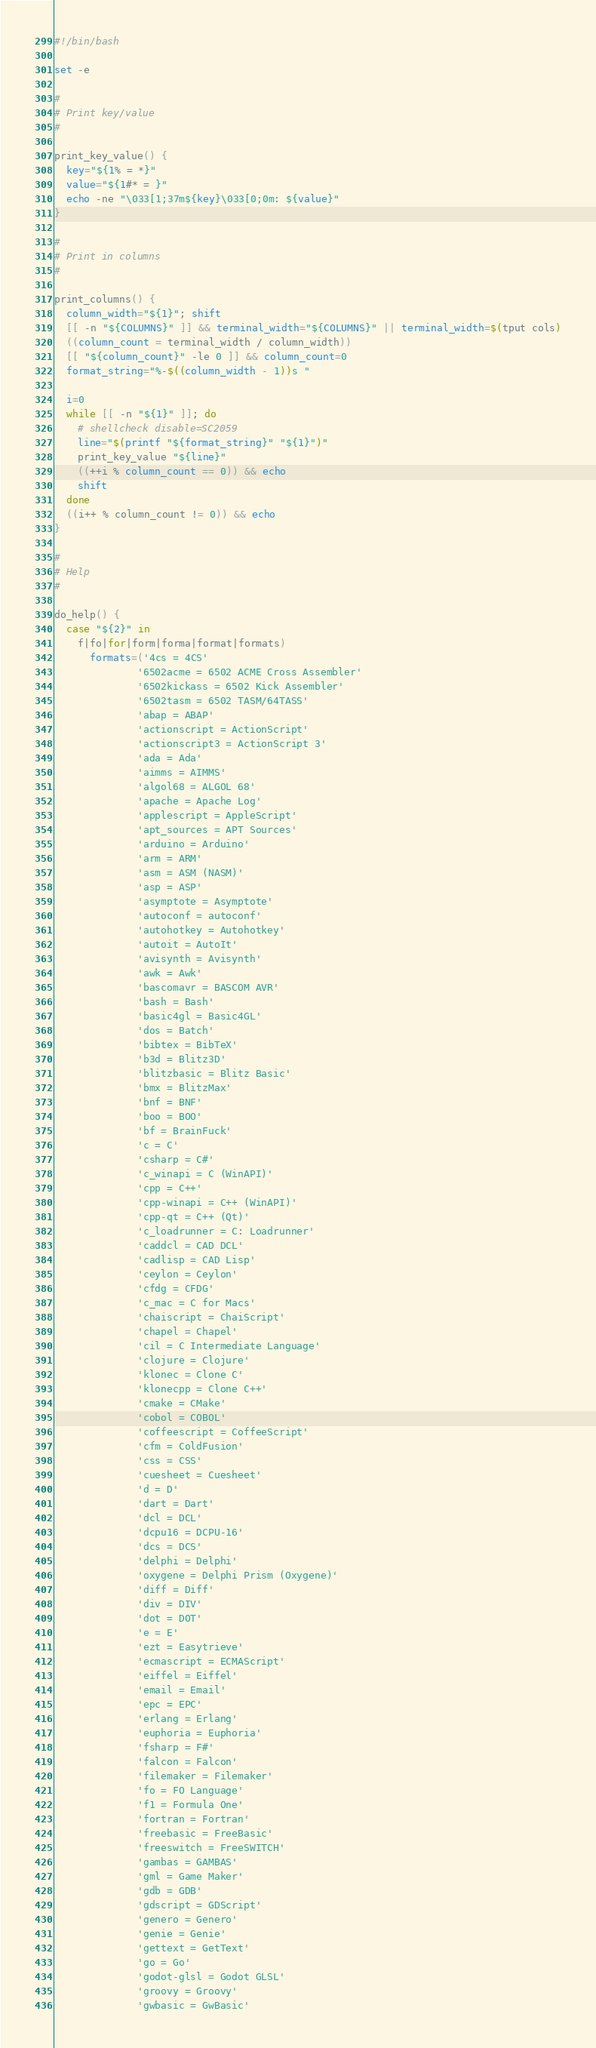<code> <loc_0><loc_0><loc_500><loc_500><_Bash_>#!/bin/bash

set -e

#
# Print key/value
#

print_key_value() {
  key="${1% = *}"
  value="${1#* = }"
  echo -ne "\033[1;37m${key}\033[0;0m: ${value}"
}

#
# Print in columns
#

print_columns() {
  column_width="${1}"; shift
  [[ -n "${COLUMNS}" ]] && terminal_width="${COLUMNS}" || terminal_width=$(tput cols)
  ((column_count = terminal_width / column_width))
  [[ "${column_count}" -le 0 ]] && column_count=0
  format_string="%-$((column_width - 1))s "

  i=0
  while [[ -n "${1}" ]]; do
    # shellcheck disable=SC2059
    line="$(printf "${format_string}" "${1}")"
    print_key_value "${line}"
    ((++i % column_count == 0)) && echo
    shift
  done
  ((i++ % column_count != 0)) && echo
}

#
# Help
#

do_help() {
  case "${2}" in
    f|fo|for|form|forma|format|formats)
      formats=('4cs = 4CS'
              '6502acme = 6502 ACME Cross Assembler'
              '6502kickass = 6502 Kick Assembler'
              '6502tasm = 6502 TASM/64TASS'
              'abap = ABAP'
              'actionscript = ActionScript'
              'actionscript3 = ActionScript 3'
              'ada = Ada'
              'aimms = AIMMS'
              'algol68 = ALGOL 68'
              'apache = Apache Log'
              'applescript = AppleScript'
              'apt_sources = APT Sources'
              'arduino = Arduino'
              'arm = ARM'
              'asm = ASM (NASM)'
              'asp = ASP'
              'asymptote = Asymptote'
              'autoconf = autoconf'
              'autohotkey = Autohotkey'
              'autoit = AutoIt'
              'avisynth = Avisynth'
              'awk = Awk'
              'bascomavr = BASCOM AVR'
              'bash = Bash'
              'basic4gl = Basic4GL'
              'dos = Batch'
              'bibtex = BibTeX'
              'b3d = Blitz3D'
              'blitzbasic = Blitz Basic'
              'bmx = BlitzMax'
              'bnf = BNF'
              'boo = BOO'
              'bf = BrainFuck'
              'c = C'
              'csharp = C#'
              'c_winapi = C (WinAPI)'
              'cpp = C++'
              'cpp-winapi = C++ (WinAPI)'
              'cpp-qt = C++ (Qt)'
              'c_loadrunner = C: Loadrunner'
              'caddcl = CAD DCL'
              'cadlisp = CAD Lisp'
              'ceylon = Ceylon'
              'cfdg = CFDG'
              'c_mac = C for Macs'
              'chaiscript = ChaiScript'
              'chapel = Chapel'
              'cil = C Intermediate Language'
              'clojure = Clojure'
              'klonec = Clone C'
              'klonecpp = Clone C++'
              'cmake = CMake'
              'cobol = COBOL'
              'coffeescript = CoffeeScript'
              'cfm = ColdFusion'
              'css = CSS'
              'cuesheet = Cuesheet'
              'd = D'
              'dart = Dart'
              'dcl = DCL'
              'dcpu16 = DCPU-16'
              'dcs = DCS'
              'delphi = Delphi'
              'oxygene = Delphi Prism (Oxygene)'
              'diff = Diff'
              'div = DIV'
              'dot = DOT'
              'e = E'
              'ezt = Easytrieve'
              'ecmascript = ECMAScript'
              'eiffel = Eiffel'
              'email = Email'
              'epc = EPC'
              'erlang = Erlang'
              'euphoria = Euphoria'
              'fsharp = F#'
              'falcon = Falcon'
              'filemaker = Filemaker'
              'fo = FO Language'
              'f1 = Formula One'
              'fortran = Fortran'
              'freebasic = FreeBasic'
              'freeswitch = FreeSWITCH'
              'gambas = GAMBAS'
              'gml = Game Maker'
              'gdb = GDB'
              'gdscript = GDScript'
              'genero = Genero'
              'genie = Genie'
              'gettext = GetText'
              'go = Go'
              'godot-glsl = Godot GLSL'
              'groovy = Groovy'
              'gwbasic = GwBasic'</code> 